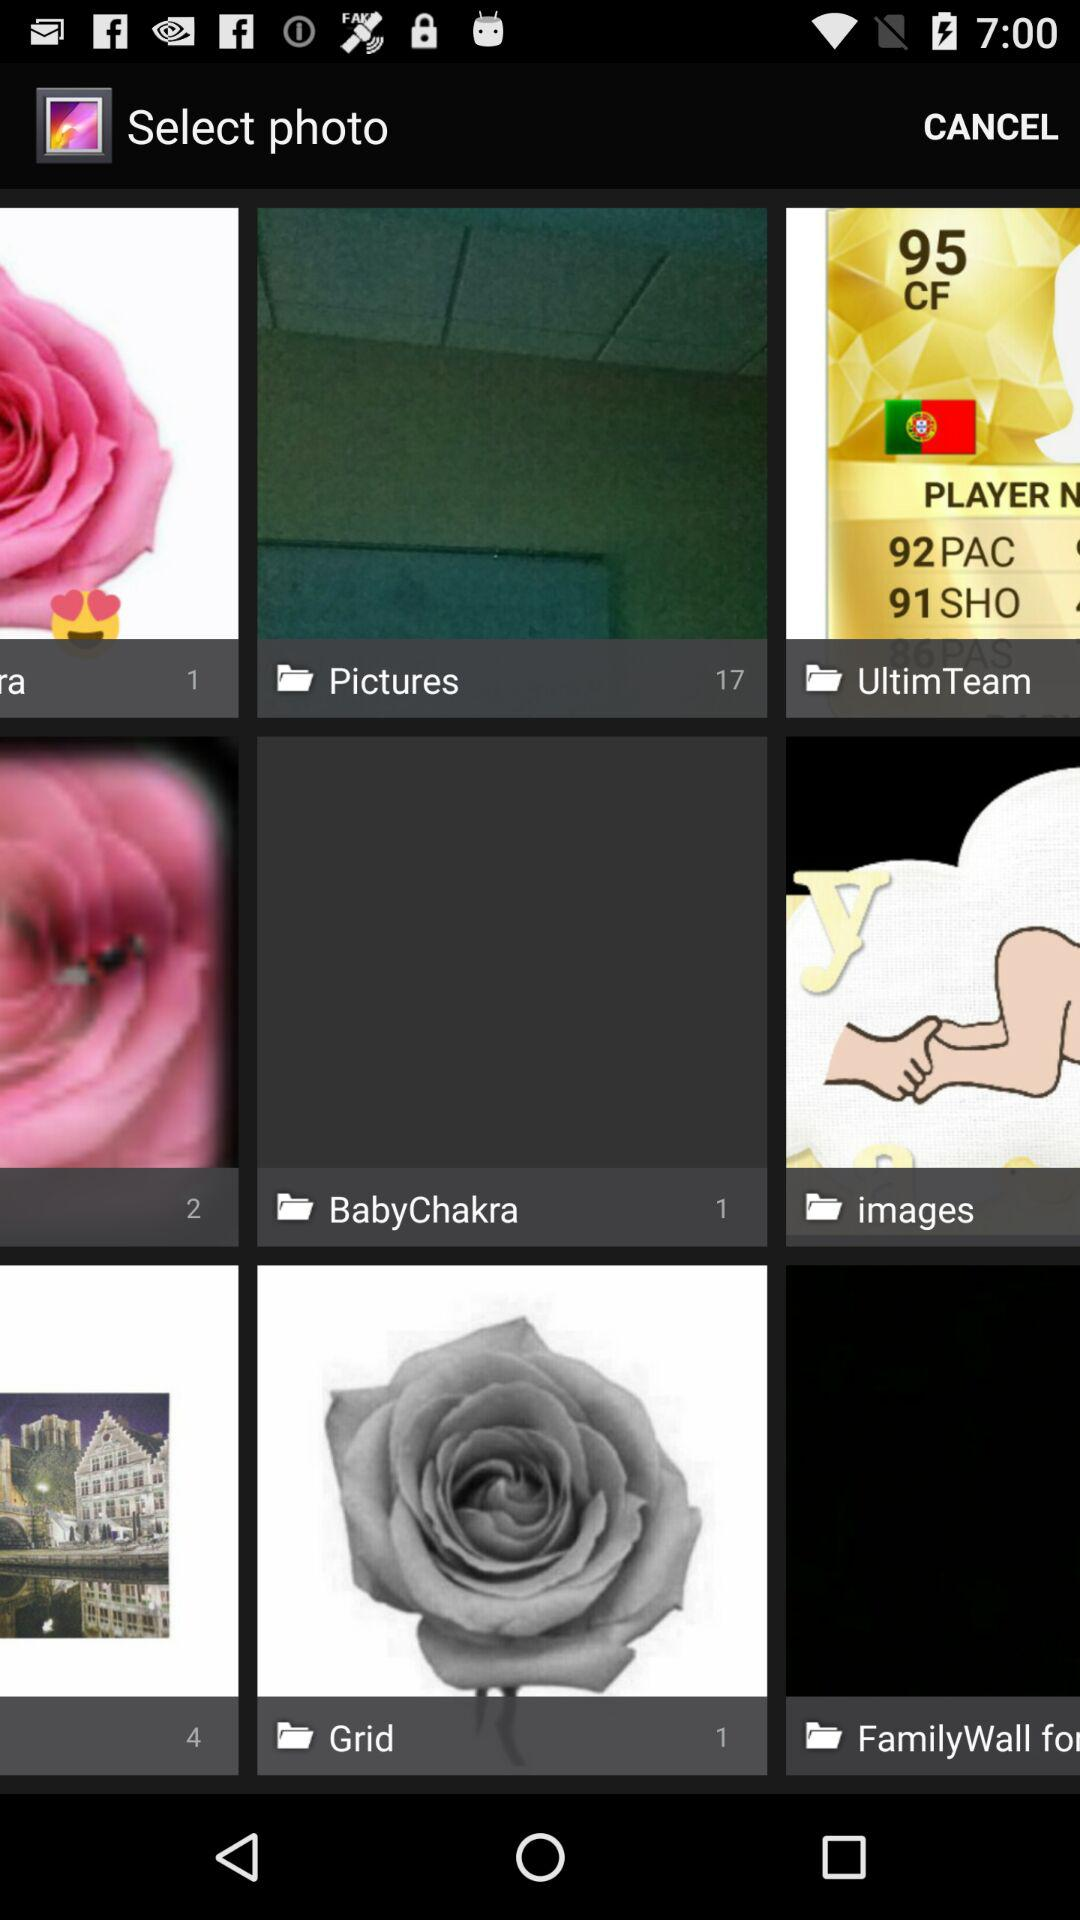How many pictures are in the "Grid" folder? There is 1 picture in the "Grid" folder. 